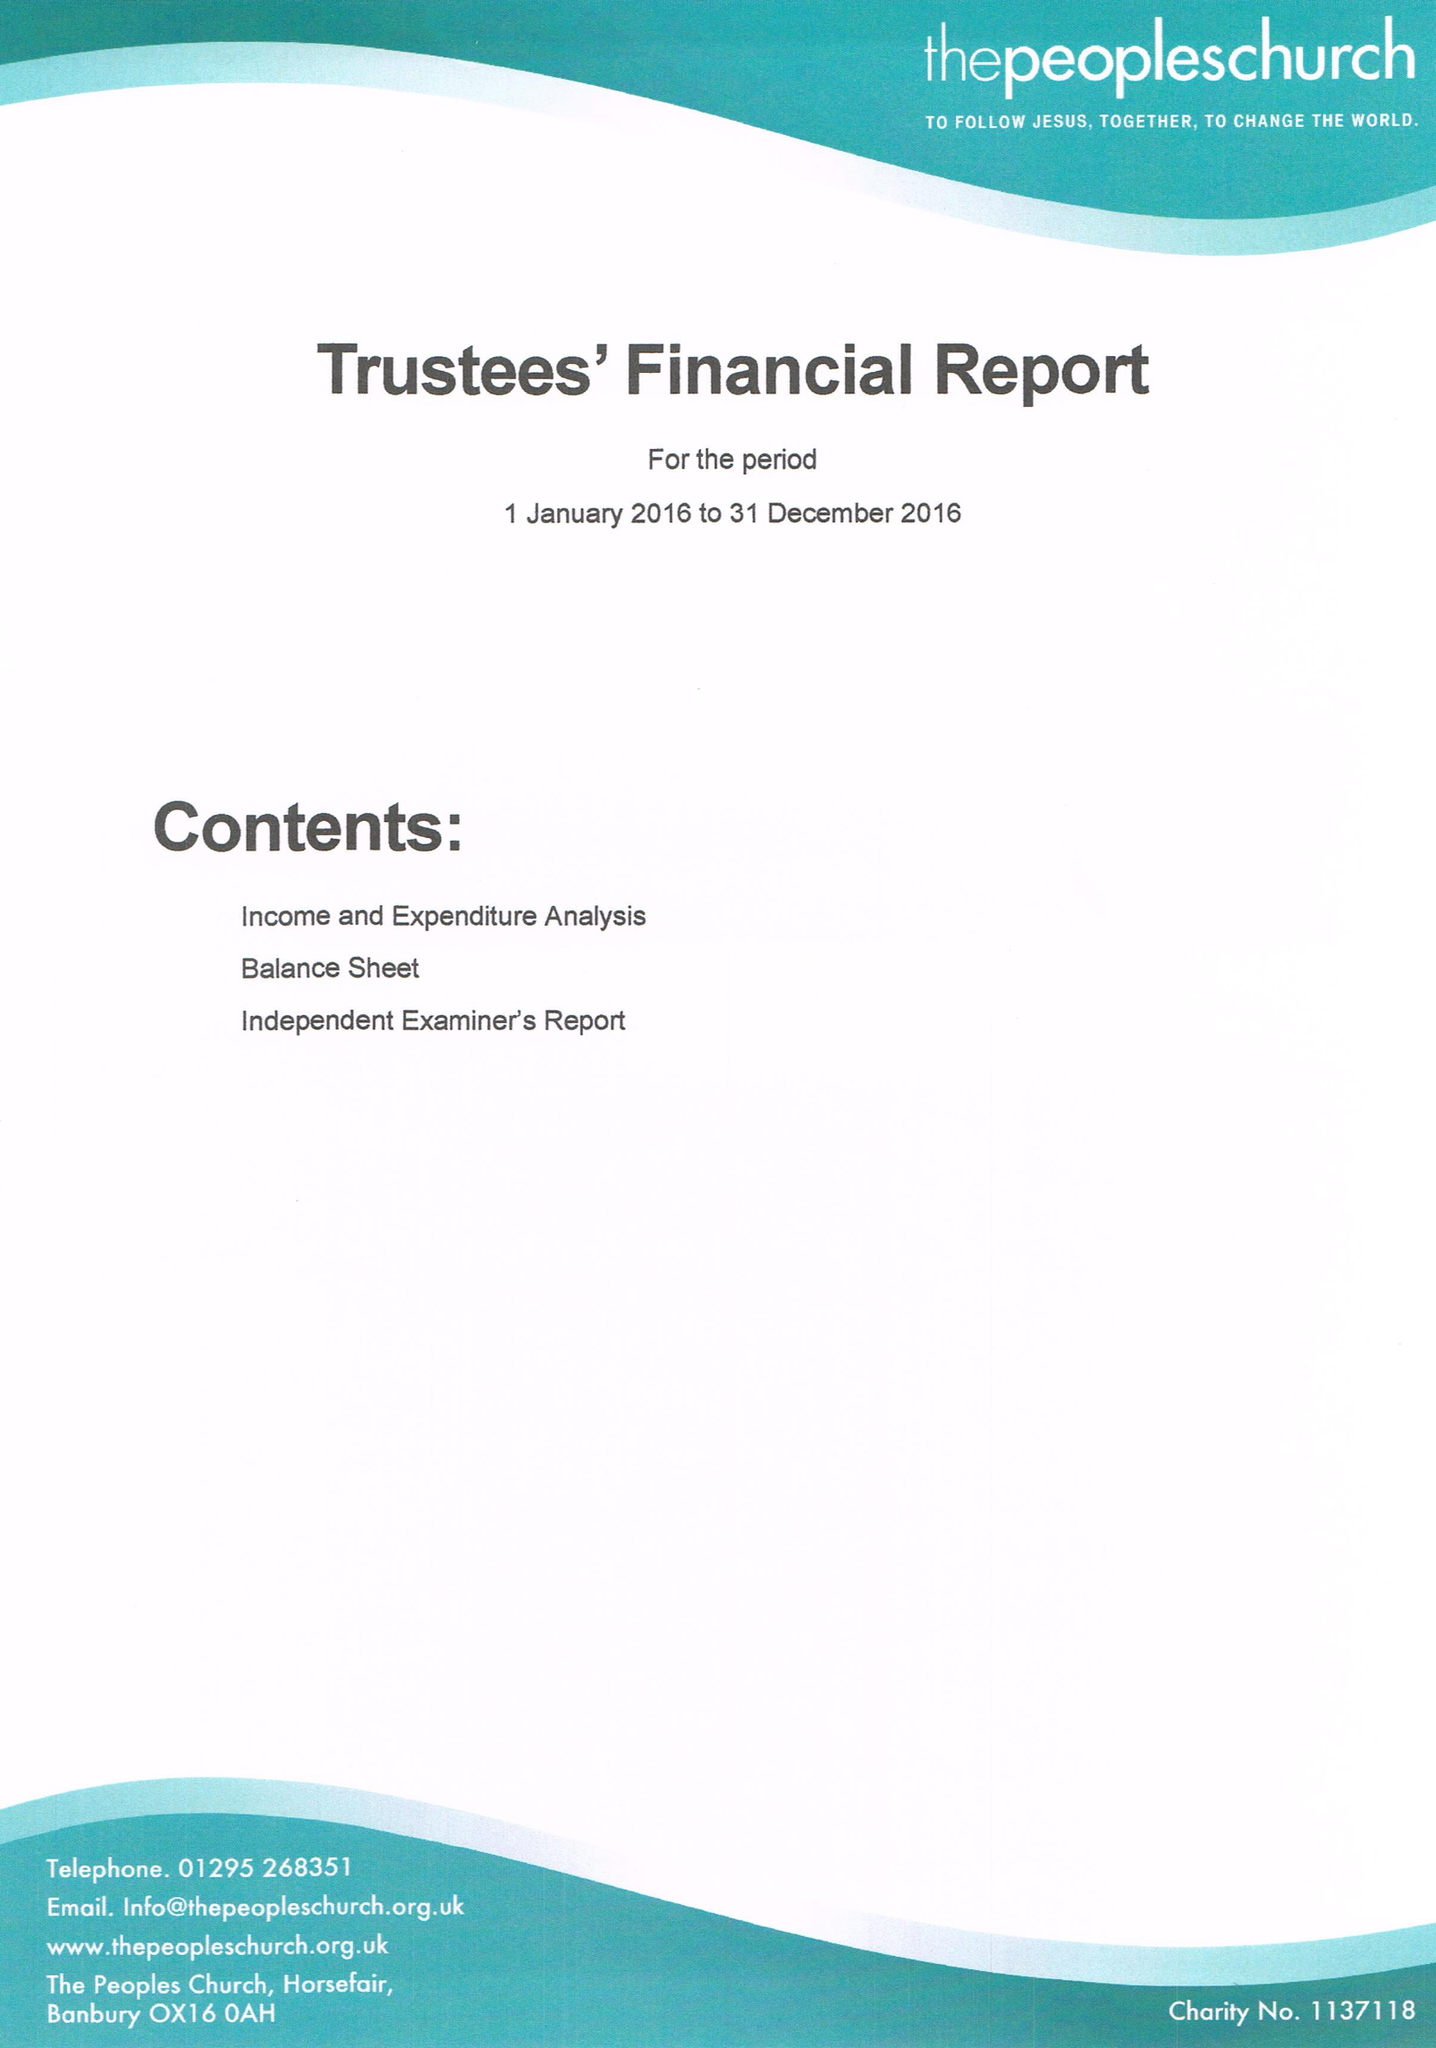What is the value for the spending_annually_in_british_pounds?
Answer the question using a single word or phrase. 164151.54 